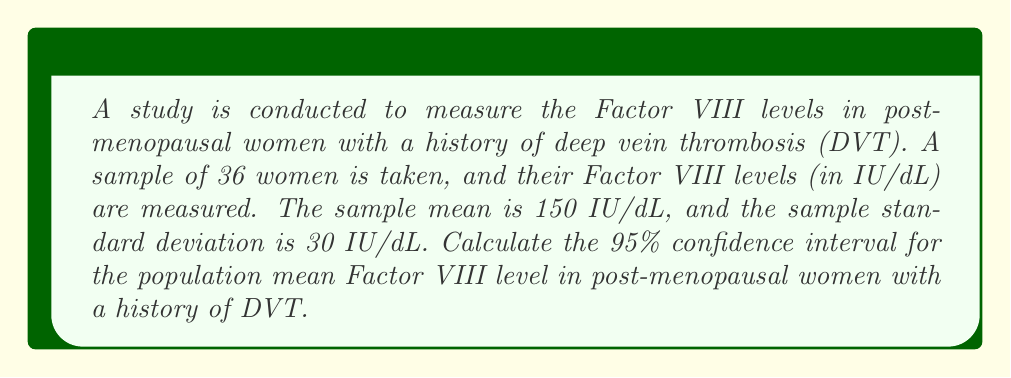Provide a solution to this math problem. To calculate the confidence interval, we'll follow these steps:

1. Identify the known values:
   - Sample size (n) = 36
   - Sample mean ($\bar{x}$) = 150 IU/dL
   - Sample standard deviation (s) = 30 IU/dL
   - Confidence level = 95%

2. Determine the critical value:
   For a 95% confidence interval with df = 35 (n - 1), we use t-distribution.
   The critical value is $t_{0.025, 35} = 2.030$ (from t-table)

3. Calculate the standard error of the mean (SEM):
   $SEM = \frac{s}{\sqrt{n}} = \frac{30}{\sqrt{36}} = 5$ IU/dL

4. Calculate the margin of error:
   $Margin of Error = t_{critical} \times SEM = 2.030 \times 5 = 10.15$ IU/dL

5. Calculate the confidence interval:
   $CI = \bar{x} \pm Margin of Error$
   $CI = 150 \pm 10.15$
   Lower bound: $150 - 10.15 = 139.85$ IU/dL
   Upper bound: $150 + 10.15 = 160.15$ IU/dL

Therefore, the 95% confidence interval for the population mean Factor VIII level is (139.85, 160.15) IU/dL.
Answer: (139.85, 160.15) IU/dL 